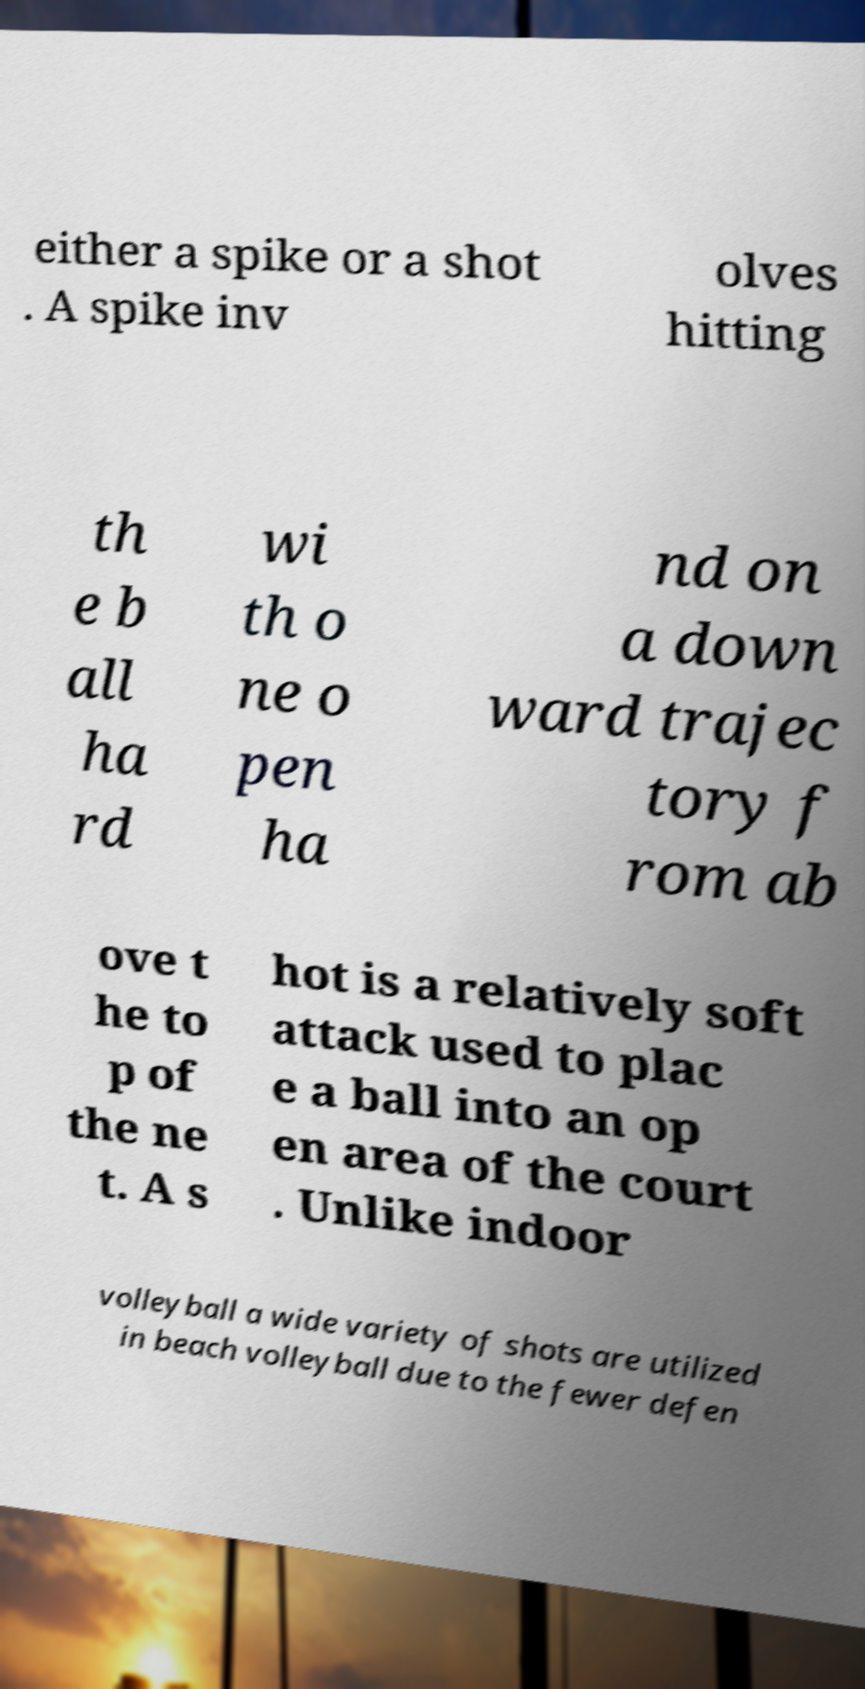What messages or text are displayed in this image? I need them in a readable, typed format. either a spike or a shot . A spike inv olves hitting th e b all ha rd wi th o ne o pen ha nd on a down ward trajec tory f rom ab ove t he to p of the ne t. A s hot is a relatively soft attack used to plac e a ball into an op en area of the court . Unlike indoor volleyball a wide variety of shots are utilized in beach volleyball due to the fewer defen 